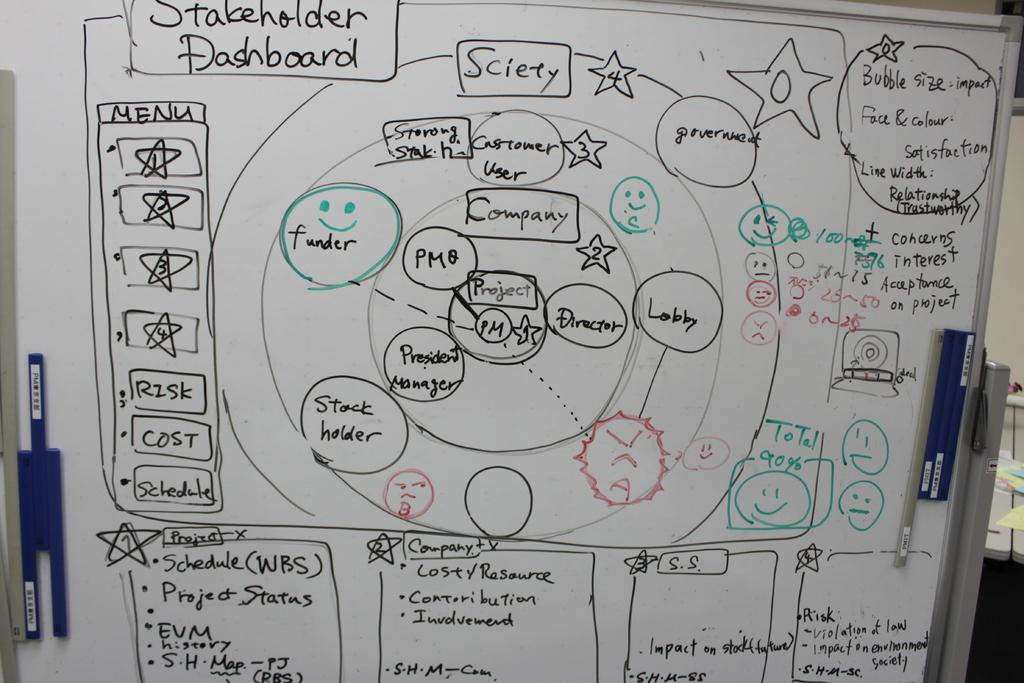<image>
Render a clear and concise summary of the photo. Circular drawings including lobby on the Stakeholder Dashboard. 